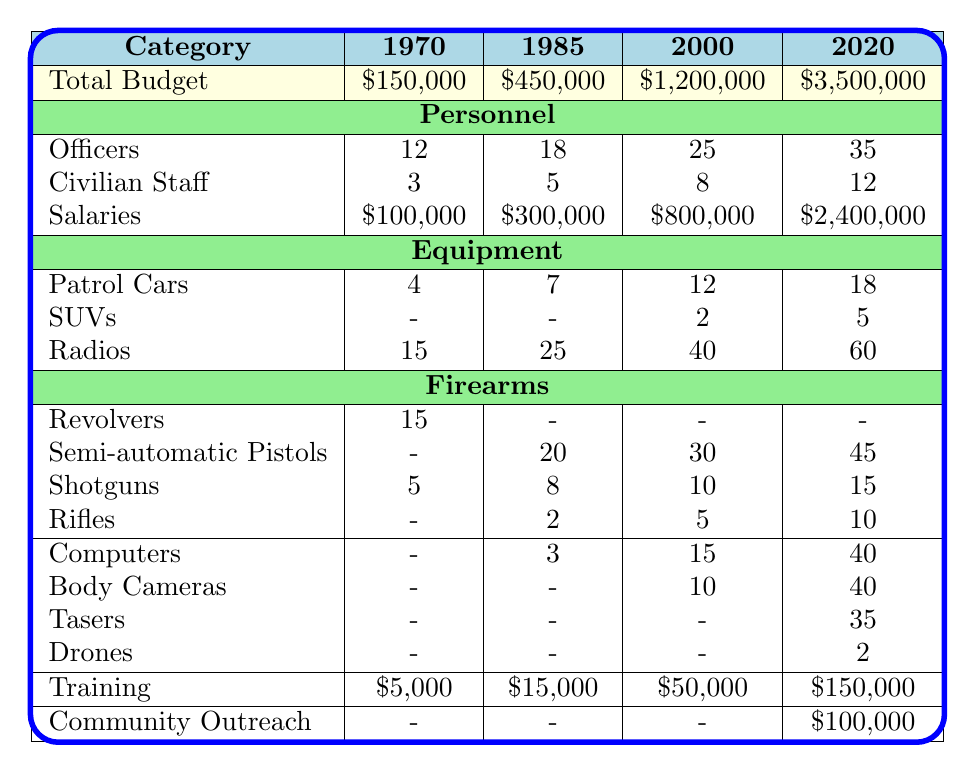What was the total budget for the Hillsdale Police Department in 2000? The table shows that the total budget for the year 2000 is listed as $1,200,000.
Answer: $1,200,000 How many officers were employed in 1985? According to the table, the number of officers in 1985 is indicated as 18.
Answer: 18 What is the increase in the total budget from 1970 to 2020? The budget in 1970 was $150,000 and in 2020 it was $3,500,000. The increase is calculated as $3,500,000 - $150,000 = $3,350,000.
Answer: $3,350,000 How many patrol cars were acquired between 2000 and 2020? In 2000, there were 12 patrol cars, and in 2020 there were 18. The number of patrol cars acquired is 18 - 12 = 6.
Answer: 6 What proportion of the total budget in 2020 was allocated for training? The total budget in 2020 was $3,500,000, and training costs were $150,000. The proportion is calculated as $150,000 / $3,500,000 = 0.042857, or about 4.29%.
Answer: 4.29% Did the Hillsdale Police Department acquire drones before 2020? The table indicates that drones were listed as an acquisition in 2020, meaning they were not present in earlier years.
Answer: No Which year saw the highest number of civilian staff? The table shows that in 2020, the Hillsdale Police Department had 12 civilian staff, which is more than any other year listed.
Answer: 2020 What was the average number of officers over the years represented in the table? The total number of officers across the years (12 + 18 + 25 + 35) is 90. Since there are 4 years, the average is 90 / 4 = 22.5.
Answer: 22.5 What types of firearms were first acquired in 1985 according to this table? The table indicates that in 1985, the police department acquired semi-automatic pistols (20) and shotguns (8), which were not listed before that year.
Answer: Semi-automatic pistols and shotguns How much did the Hillsdale Police Department spend on community outreach in 2020 compared to training? In 2020, community outreach spending was $100,000, while training costs were $150,000. The difference is $150,000 - $100,000 = $50,000.
Answer: $50,000 In which year did the number of rifles first reach 5? The data shows that rifles were listed in 2000 with a count of 5, indicating this was the first occurrence to reach that number.
Answer: 2000 